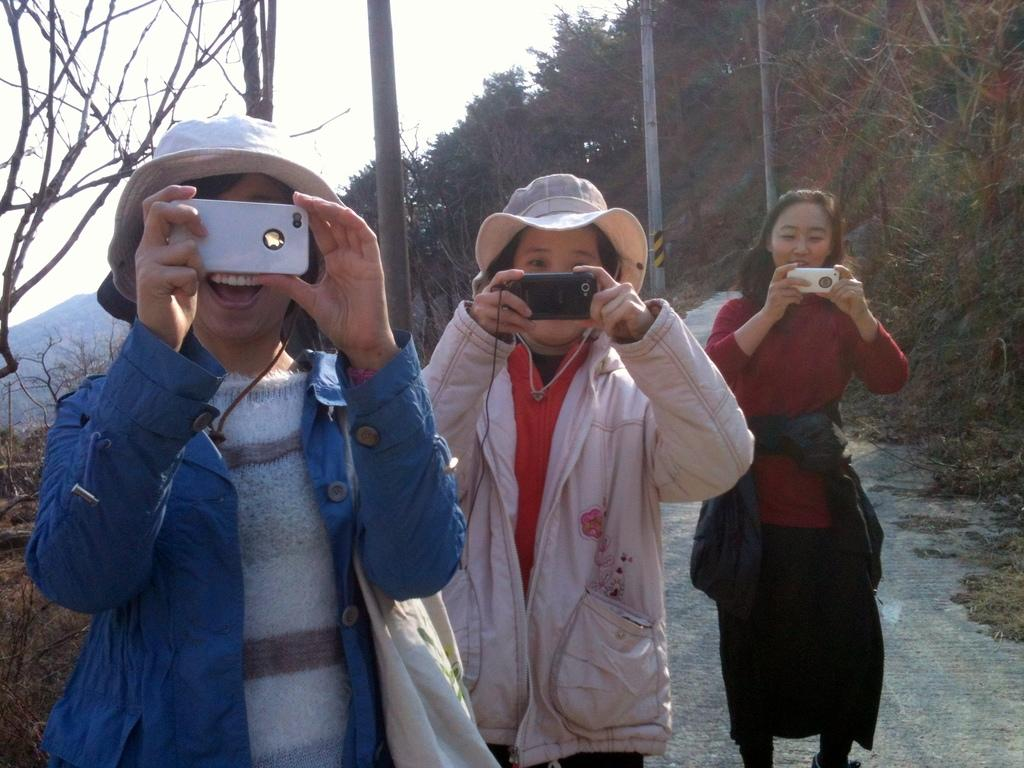How many women are present in the image? There are three women in the image. What are the women doing in the image? The women are standing and holding cameras. Can you describe the clothing of the women? Two of the women are wearing caps and jackets. What can be seen in the background of the image? There are trees and the sky visible in the background of the image. What type of oatmeal is being served in the image? There is no oatmeal present in the image; it features three women holding cameras. Can you tell me the existence of a spot on the ground in the image? The provided facts do not mention any spots on the ground, so it cannot be determined from the image. 